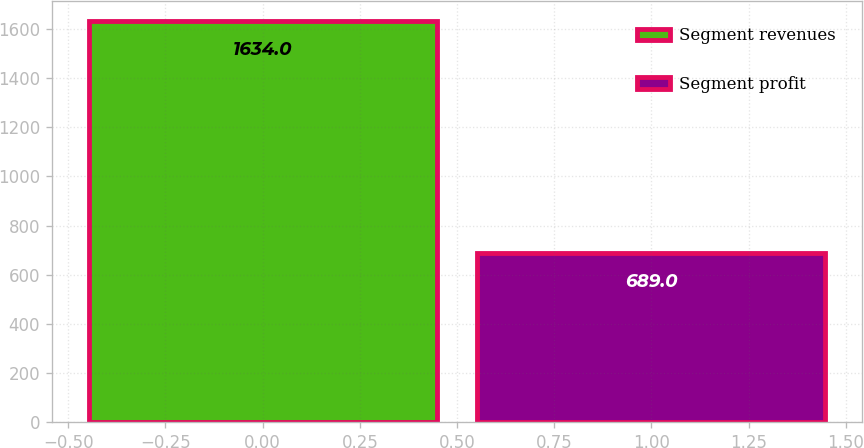Convert chart to OTSL. <chart><loc_0><loc_0><loc_500><loc_500><bar_chart><fcel>Segment revenues<fcel>Segment profit<nl><fcel>1634<fcel>689<nl></chart> 